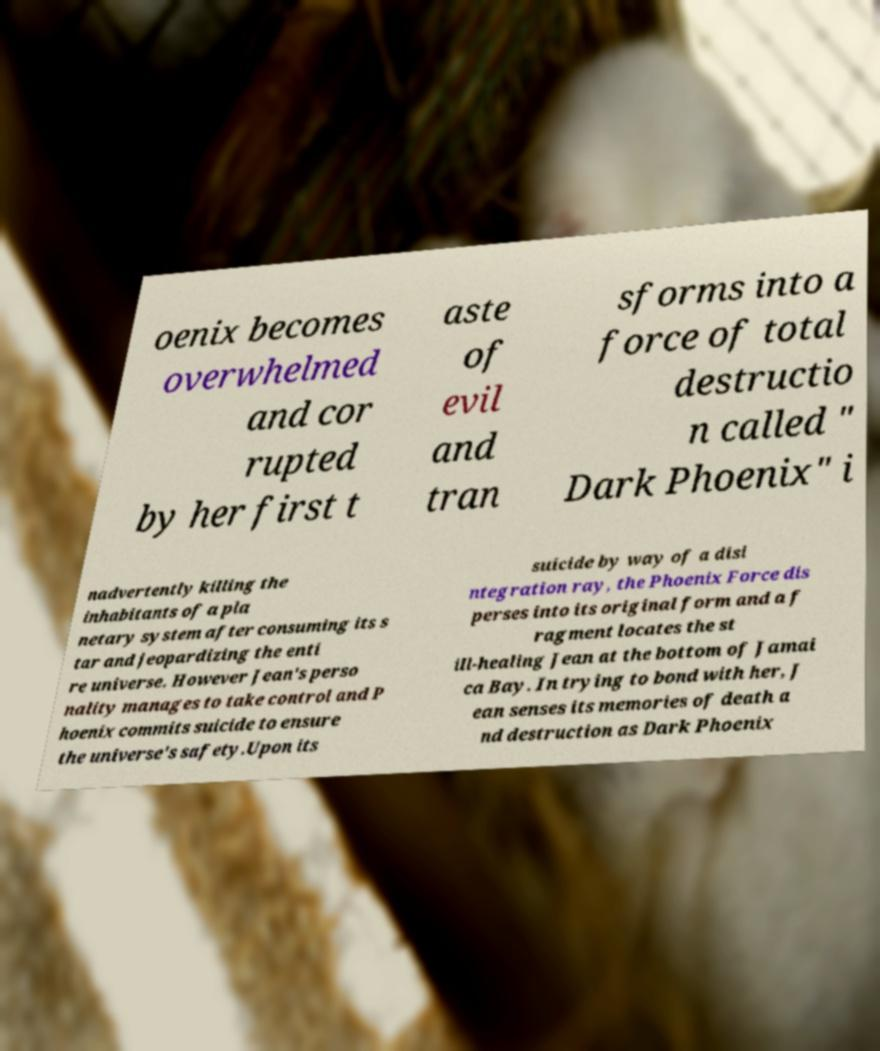Please identify and transcribe the text found in this image. oenix becomes overwhelmed and cor rupted by her first t aste of evil and tran sforms into a force of total destructio n called " Dark Phoenix" i nadvertently killing the inhabitants of a pla netary system after consuming its s tar and jeopardizing the enti re universe. However Jean's perso nality manages to take control and P hoenix commits suicide to ensure the universe's safety.Upon its suicide by way of a disi ntegration ray, the Phoenix Force dis perses into its original form and a f ragment locates the st ill-healing Jean at the bottom of Jamai ca Bay. In trying to bond with her, J ean senses its memories of death a nd destruction as Dark Phoenix 